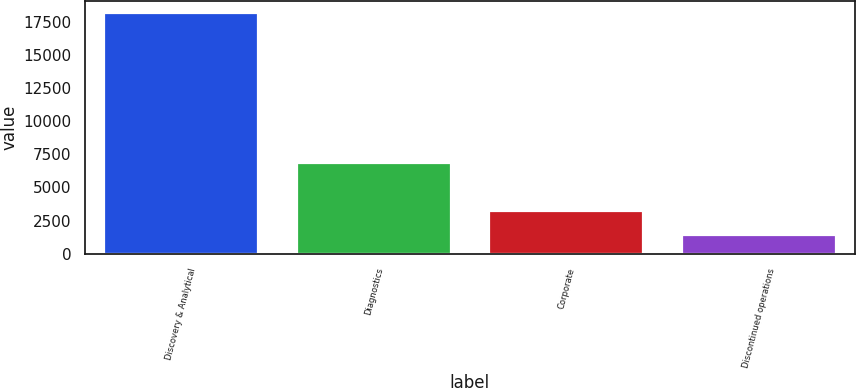Convert chart to OTSL. <chart><loc_0><loc_0><loc_500><loc_500><bar_chart><fcel>Discovery & Analytical<fcel>Diagnostics<fcel>Corporate<fcel>Discontinued operations<nl><fcel>18175<fcel>6854<fcel>3189<fcel>1414<nl></chart> 